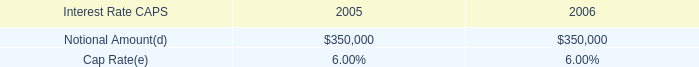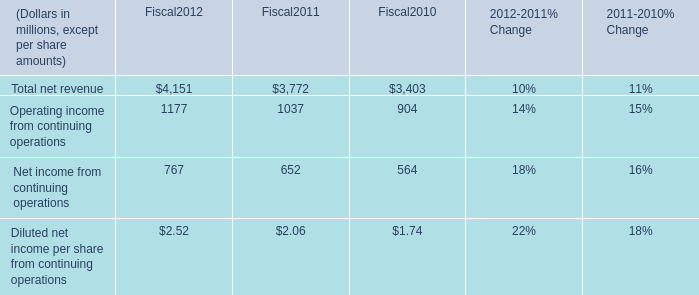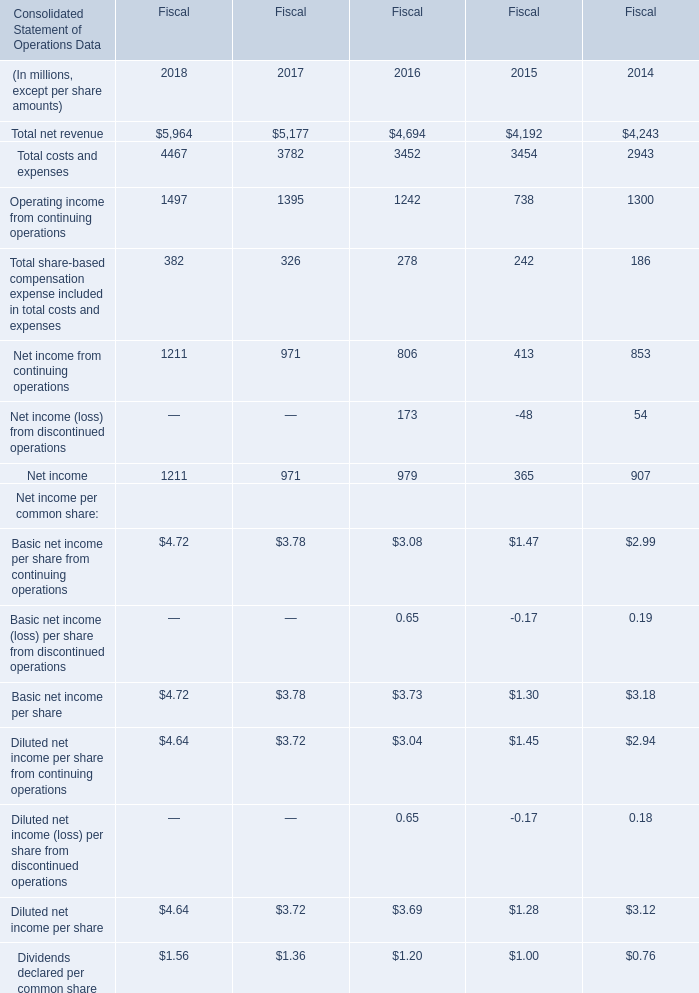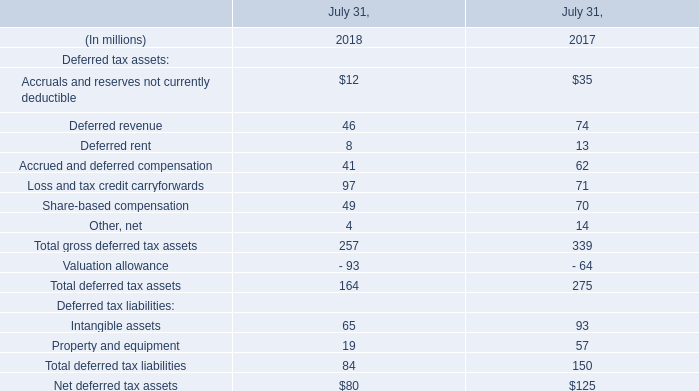what was the ratio of the re-measurement gain from 2005 to 2004 
Computations: (396000 / 146000)
Answer: 2.71233. 